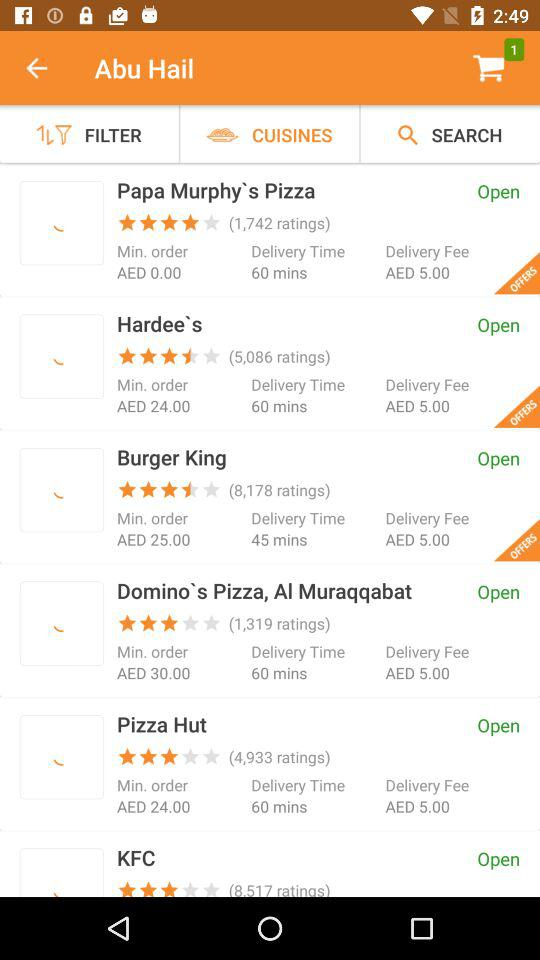What is the rating of "Burger King"? The rating is 3.5 stars. 